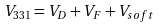<formula> <loc_0><loc_0><loc_500><loc_500>V _ { 3 3 1 } = V _ { D } + V _ { F } + V _ { s o f t }</formula> 